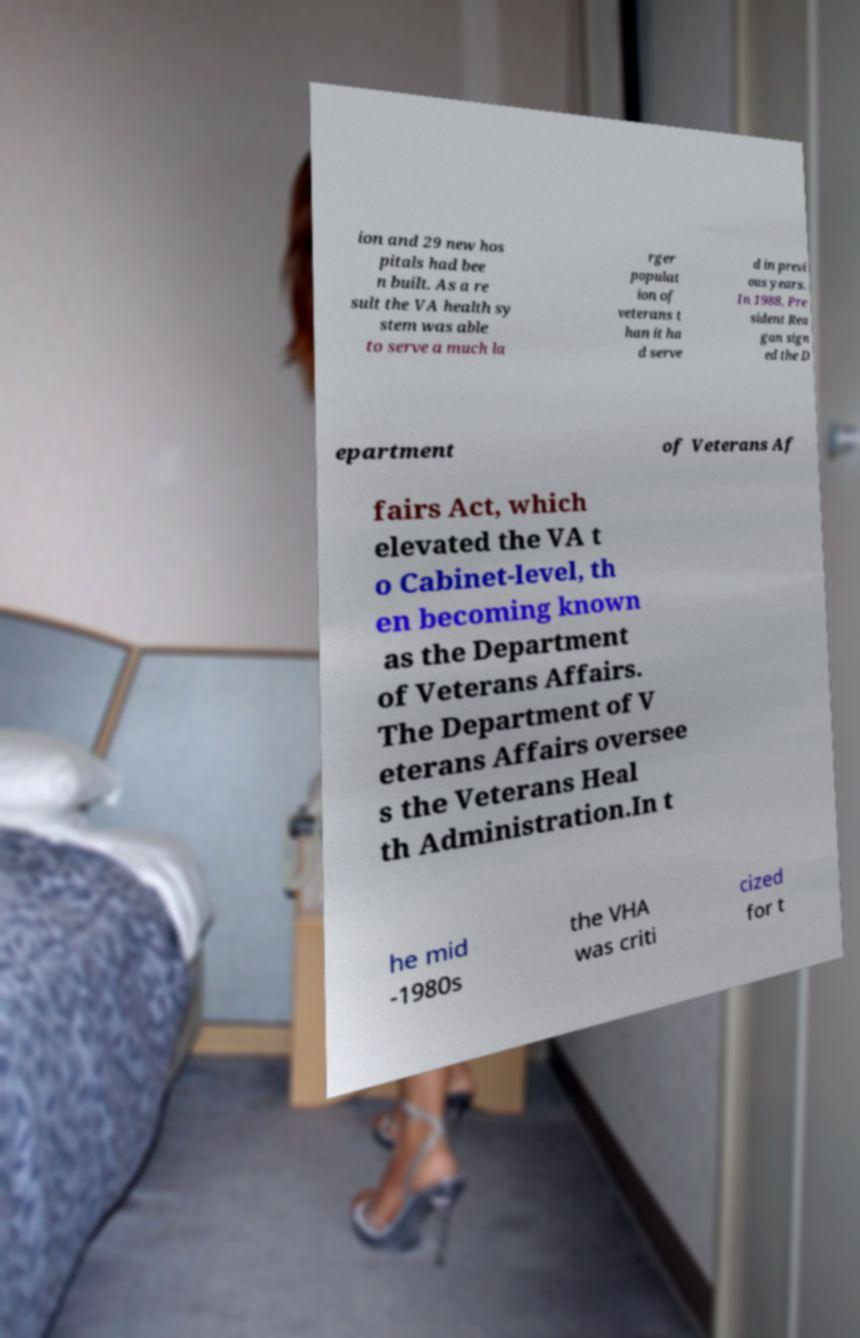There's text embedded in this image that I need extracted. Can you transcribe it verbatim? ion and 29 new hos pitals had bee n built. As a re sult the VA health sy stem was able to serve a much la rger populat ion of veterans t han it ha d serve d in previ ous years. In 1988, Pre sident Rea gan sign ed the D epartment of Veterans Af fairs Act, which elevated the VA t o Cabinet-level, th en becoming known as the Department of Veterans Affairs. The Department of V eterans Affairs oversee s the Veterans Heal th Administration.In t he mid -1980s the VHA was criti cized for t 